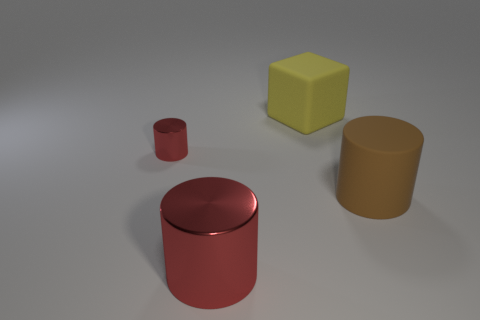What number of small cylinders have the same material as the yellow block?
Offer a terse response. 0. What is the shape of the tiny shiny object that is the same color as the big metal cylinder?
Offer a terse response. Cylinder. What is the size of the red metallic cylinder that is behind the cylinder right of the big yellow block?
Keep it short and to the point. Small. Do the matte object that is left of the brown matte object and the big matte object to the right of the cube have the same shape?
Ensure brevity in your answer.  No. Is the number of large objects to the left of the small red shiny cylinder the same as the number of red things?
Offer a very short reply. No. What is the color of the other shiny object that is the same shape as the small red shiny object?
Your answer should be very brief. Red. Do the large object to the left of the big yellow matte object and the yellow block have the same material?
Keep it short and to the point. No. How many large things are brown matte things or red cylinders?
Provide a short and direct response. 2. The block is what size?
Keep it short and to the point. Large. There is a rubber cylinder; is its size the same as the red shiny cylinder that is in front of the brown matte thing?
Give a very brief answer. Yes. 